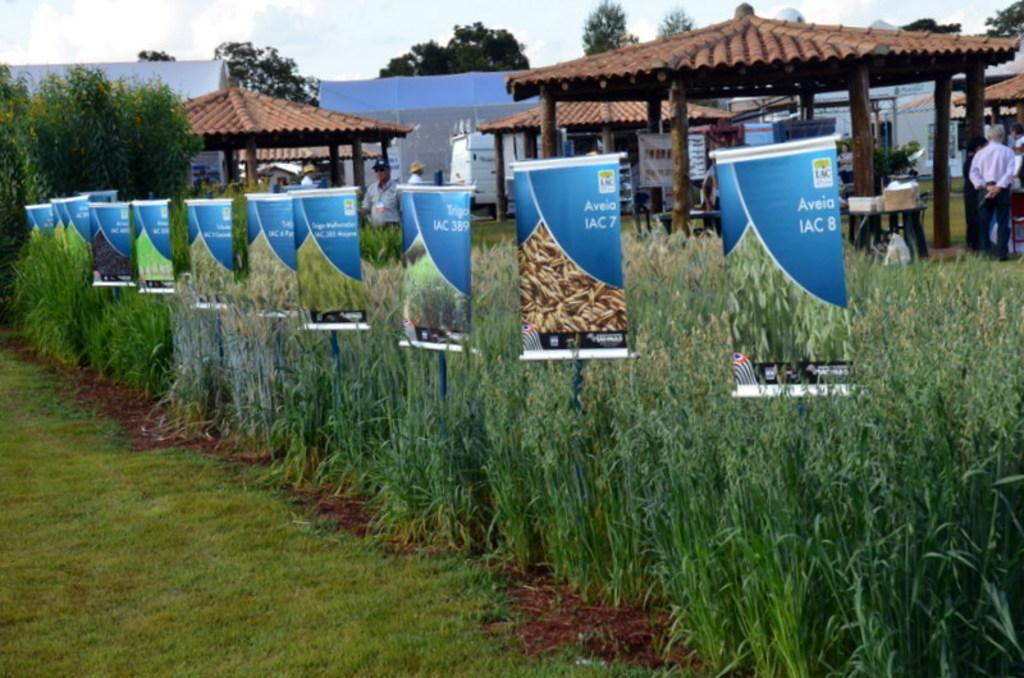What is located in the middle of the image? There are plants, crops, and posters in the middle of the image. Can you describe the background of the image? In the background of the image, there are many people, vehicles, houses, tents, trees, tables, boxes, and the sky with clouds is visible. What type of soup is being served in the morning in the image? There is no soup or morning scene present in the image. 